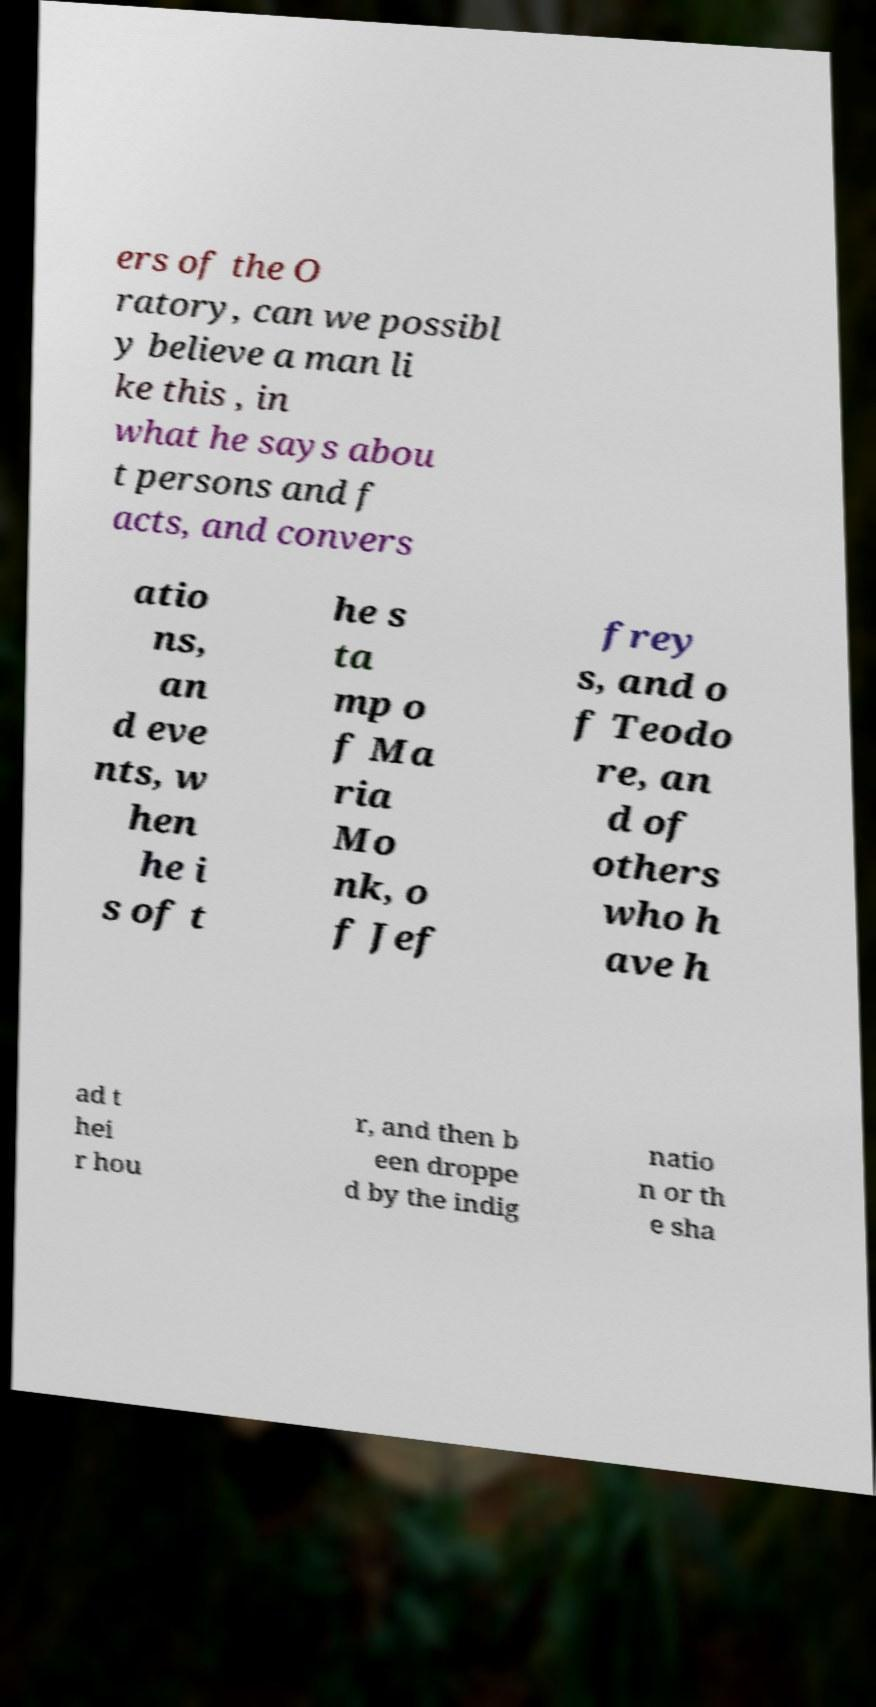Can you read and provide the text displayed in the image?This photo seems to have some interesting text. Can you extract and type it out for me? ers of the O ratory, can we possibl y believe a man li ke this , in what he says abou t persons and f acts, and convers atio ns, an d eve nts, w hen he i s of t he s ta mp o f Ma ria Mo nk, o f Jef frey s, and o f Teodo re, an d of others who h ave h ad t hei r hou r, and then b een droppe d by the indig natio n or th e sha 